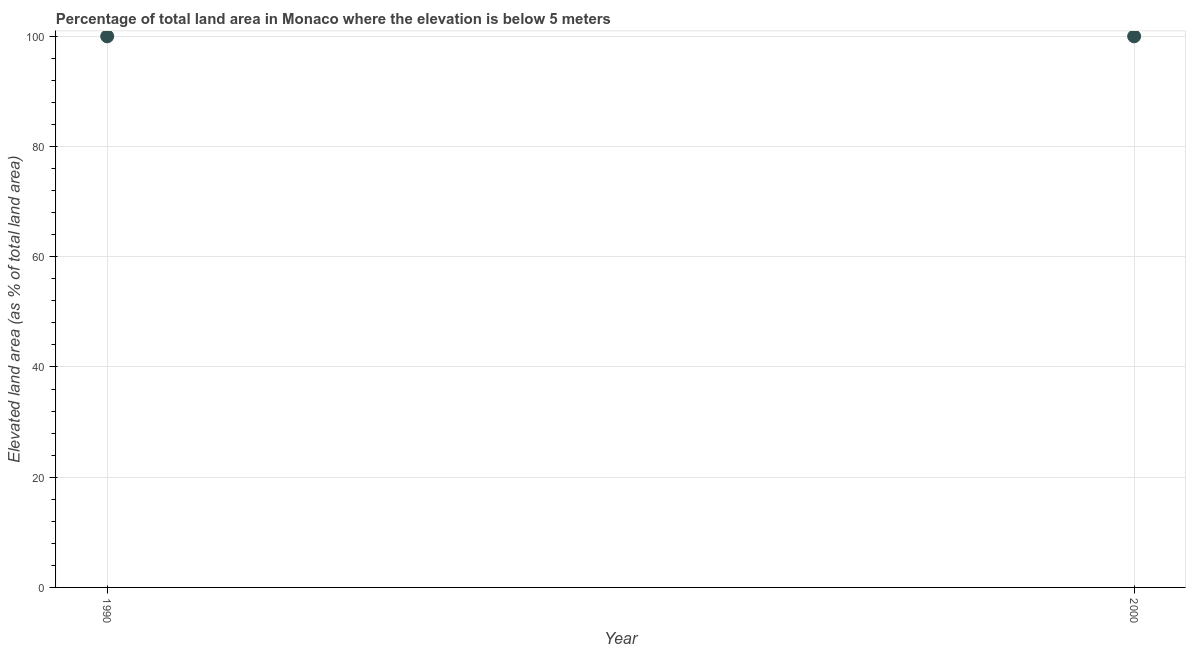What is the total elevated land area in 1990?
Offer a terse response. 100. Across all years, what is the maximum total elevated land area?
Your answer should be very brief. 100. Across all years, what is the minimum total elevated land area?
Ensure brevity in your answer.  100. What is the sum of the total elevated land area?
Give a very brief answer. 200. What is the difference between the total elevated land area in 1990 and 2000?
Provide a short and direct response. 0. What is the average total elevated land area per year?
Offer a terse response. 100. Do a majority of the years between 2000 and 1990 (inclusive) have total elevated land area greater than 28 %?
Provide a succinct answer. No. How many years are there in the graph?
Provide a short and direct response. 2. Does the graph contain any zero values?
Your answer should be very brief. No. Does the graph contain grids?
Offer a very short reply. Yes. What is the title of the graph?
Your answer should be very brief. Percentage of total land area in Monaco where the elevation is below 5 meters. What is the label or title of the Y-axis?
Provide a short and direct response. Elevated land area (as % of total land area). What is the Elevated land area (as % of total land area) in 2000?
Keep it short and to the point. 100. What is the difference between the Elevated land area (as % of total land area) in 1990 and 2000?
Ensure brevity in your answer.  0. 